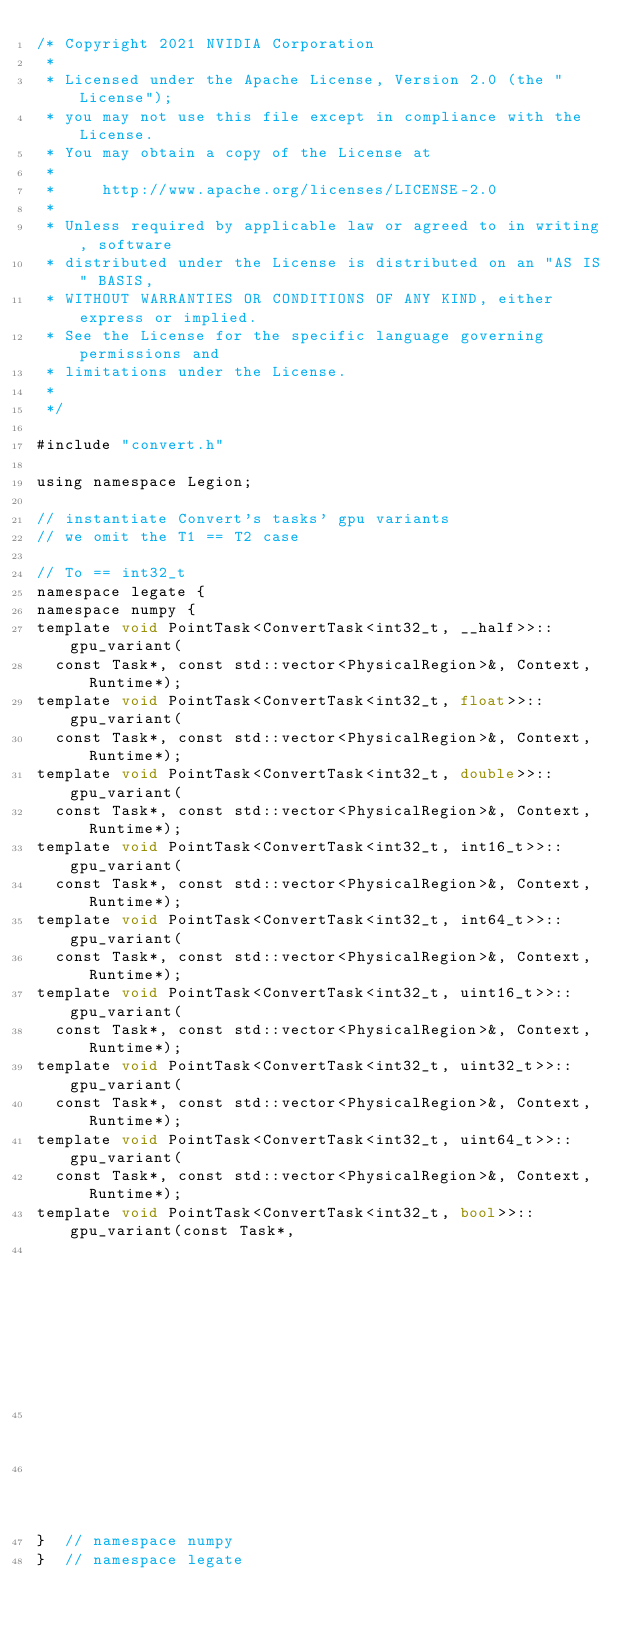<code> <loc_0><loc_0><loc_500><loc_500><_Cuda_>/* Copyright 2021 NVIDIA Corporation
 *
 * Licensed under the Apache License, Version 2.0 (the "License");
 * you may not use this file except in compliance with the License.
 * You may obtain a copy of the License at
 *
 *     http://www.apache.org/licenses/LICENSE-2.0
 *
 * Unless required by applicable law or agreed to in writing, software
 * distributed under the License is distributed on an "AS IS" BASIS,
 * WITHOUT WARRANTIES OR CONDITIONS OF ANY KIND, either express or implied.
 * See the License for the specific language governing permissions and
 * limitations under the License.
 *
 */

#include "convert.h"

using namespace Legion;

// instantiate Convert's tasks' gpu variants
// we omit the T1 == T2 case

// To == int32_t
namespace legate {
namespace numpy {
template void PointTask<ConvertTask<int32_t, __half>>::gpu_variant(
  const Task*, const std::vector<PhysicalRegion>&, Context, Runtime*);
template void PointTask<ConvertTask<int32_t, float>>::gpu_variant(
  const Task*, const std::vector<PhysicalRegion>&, Context, Runtime*);
template void PointTask<ConvertTask<int32_t, double>>::gpu_variant(
  const Task*, const std::vector<PhysicalRegion>&, Context, Runtime*);
template void PointTask<ConvertTask<int32_t, int16_t>>::gpu_variant(
  const Task*, const std::vector<PhysicalRegion>&, Context, Runtime*);
template void PointTask<ConvertTask<int32_t, int64_t>>::gpu_variant(
  const Task*, const std::vector<PhysicalRegion>&, Context, Runtime*);
template void PointTask<ConvertTask<int32_t, uint16_t>>::gpu_variant(
  const Task*, const std::vector<PhysicalRegion>&, Context, Runtime*);
template void PointTask<ConvertTask<int32_t, uint32_t>>::gpu_variant(
  const Task*, const std::vector<PhysicalRegion>&, Context, Runtime*);
template void PointTask<ConvertTask<int32_t, uint64_t>>::gpu_variant(
  const Task*, const std::vector<PhysicalRegion>&, Context, Runtime*);
template void PointTask<ConvertTask<int32_t, bool>>::gpu_variant(const Task*,
                                                                 const std::vector<PhysicalRegion>&,
                                                                 Context,
                                                                 Runtime*);
}  // namespace numpy
}  // namespace legate
</code> 